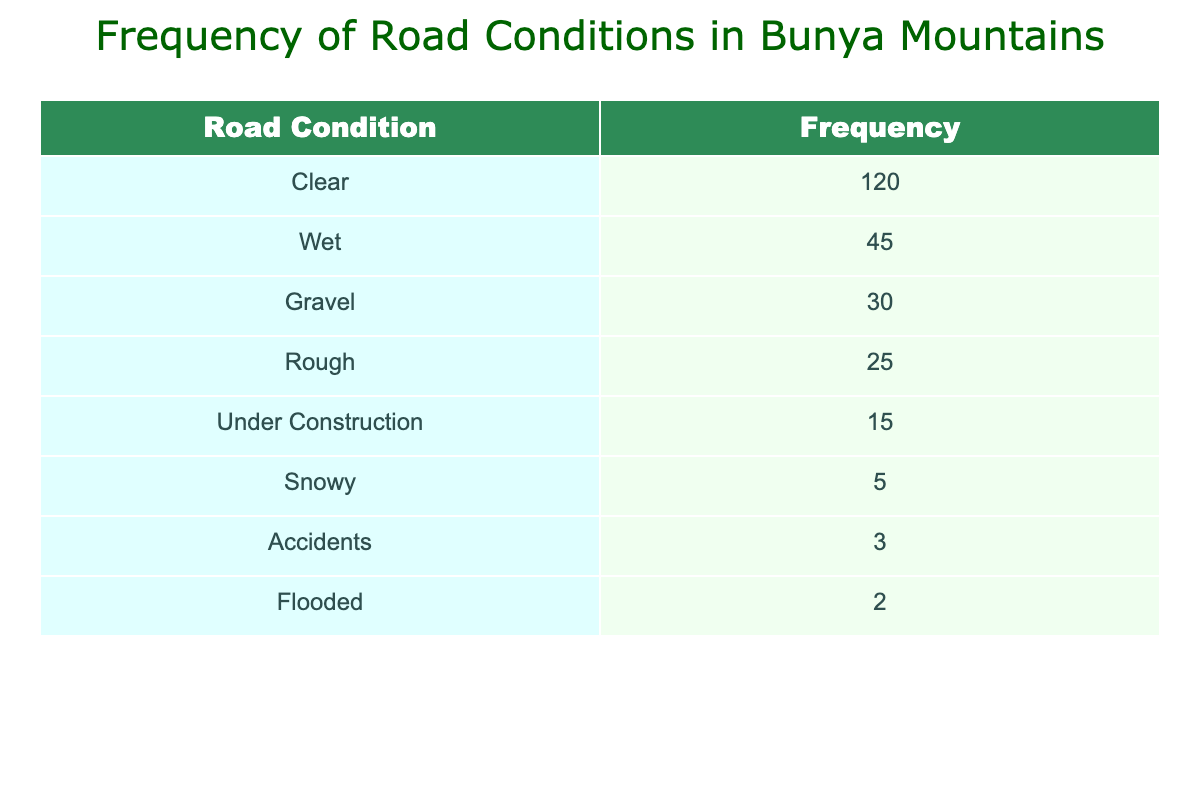What is the most frequently reported road condition in Bunya Mountains? The table shows that the road condition with the highest frequency is "Clear", which has a frequency of 120.
Answer: Clear How many travelers reported "Under Construction" as a road condition? The table indicates that 15 travelers reported "Under Construction".
Answer: 15 What is the total frequency of poor road conditions (Gravel, Rough, Accidents, Flooded, and Under Construction)? To find the total, we sum the frequencies of those conditions: Gravel (30) + Rough (25) + Accidents (3) + Flooded (2) + Under Construction (15) = 75.
Answer: 75 Is it true that the frequency of snowy road conditions is higher than that of flooded conditions? The table shows that "Snowy" has a frequency of 5, and "Flooded" has a frequency of 2. Since 5 is greater than 2, the statement is true.
Answer: Yes What is the difference in the frequency between "Wet" and "Rough" road conditions? The frequency for "Wet" is 45, and for "Rough" it is 25. The difference is 45 - 25 = 20.
Answer: 20 How many total reports of road conditions are there in the table? We find the total by summing all the frequencies: 120 + 45 + 30 + 25 + 15 + 5 + 3 + 2 = 240.
Answer: 240 What percentage of the total road conditions reported were "Accidents"? First, we find the frequency of "Accidents," which is 3. Then, we calculate the percentage by (3/240)*100 = 1.25%.
Answer: 1.25% Which road condition has the least frequency reported? The table shows that the "Flooded" condition has the least frequency with only 2 reports.
Answer: Flooded How many more travelers reported "Clear" conditions compared to "Snowy"? The frequency of "Clear" is 120, and "Snowy" is 5. The difference is 120 - 5 = 115.
Answer: 115 